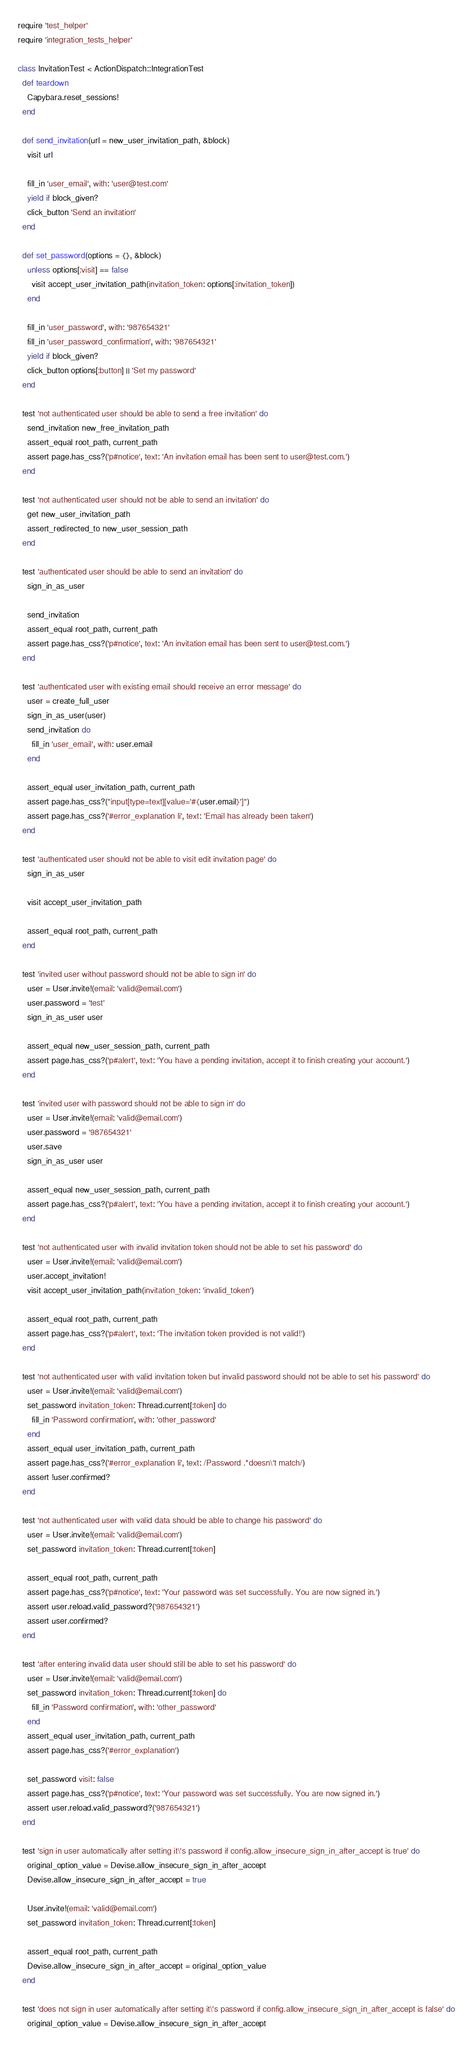<code> <loc_0><loc_0><loc_500><loc_500><_Ruby_>require 'test_helper'
require 'integration_tests_helper'

class InvitationTest < ActionDispatch::IntegrationTest
  def teardown
    Capybara.reset_sessions!
  end

  def send_invitation(url = new_user_invitation_path, &block)
    visit url

    fill_in 'user_email', with: 'user@test.com'
    yield if block_given?
    click_button 'Send an invitation'
  end

  def set_password(options = {}, &block)
    unless options[:visit] == false
      visit accept_user_invitation_path(invitation_token: options[:invitation_token])
    end

    fill_in 'user_password', with: '987654321'
    fill_in 'user_password_confirmation', with: '987654321'
    yield if block_given?
    click_button options[:button] || 'Set my password'
  end

  test 'not authenticated user should be able to send a free invitation' do
    send_invitation new_free_invitation_path
    assert_equal root_path, current_path
    assert page.has_css?('p#notice', text: 'An invitation email has been sent to user@test.com.')
  end

  test 'not authenticated user should not be able to send an invitation' do
    get new_user_invitation_path
    assert_redirected_to new_user_session_path
  end

  test 'authenticated user should be able to send an invitation' do
    sign_in_as_user

    send_invitation
    assert_equal root_path, current_path
    assert page.has_css?('p#notice', text: 'An invitation email has been sent to user@test.com.')
  end

  test 'authenticated user with existing email should receive an error message' do
    user = create_full_user
    sign_in_as_user(user)
    send_invitation do
      fill_in 'user_email', with: user.email
    end

    assert_equal user_invitation_path, current_path
    assert page.has_css?("input[type=text][value='#{user.email}']")
    assert page.has_css?('#error_explanation li', text: 'Email has already been taken')
  end

  test 'authenticated user should not be able to visit edit invitation page' do
    sign_in_as_user

    visit accept_user_invitation_path

    assert_equal root_path, current_path
  end

  test 'invited user without password should not be able to sign in' do
    user = User.invite!(email: 'valid@email.com')
    user.password = 'test'
    sign_in_as_user user

    assert_equal new_user_session_path, current_path
    assert page.has_css?('p#alert', text: 'You have a pending invitation, accept it to finish creating your account.')
  end

  test 'invited user with password should not be able to sign in' do
    user = User.invite!(email: 'valid@email.com')
    user.password = '987654321'
    user.save
    sign_in_as_user user

    assert_equal new_user_session_path, current_path
    assert page.has_css?('p#alert', text: 'You have a pending invitation, accept it to finish creating your account.')
  end

  test 'not authenticated user with invalid invitation token should not be able to set his password' do
    user = User.invite!(email: 'valid@email.com')
    user.accept_invitation!
    visit accept_user_invitation_path(invitation_token: 'invalid_token')

    assert_equal root_path, current_path
    assert page.has_css?('p#alert', text: 'The invitation token provided is not valid!')
  end

  test 'not authenticated user with valid invitation token but invalid password should not be able to set his password' do
    user = User.invite!(email: 'valid@email.com')
    set_password invitation_token: Thread.current[:token] do
      fill_in 'Password confirmation', with: 'other_password'
    end
    assert_equal user_invitation_path, current_path
    assert page.has_css?('#error_explanation li', text: /Password .*doesn\'t match/)
    assert !user.confirmed?
  end

  test 'not authenticated user with valid data should be able to change his password' do
    user = User.invite!(email: 'valid@email.com')
    set_password invitation_token: Thread.current[:token]

    assert_equal root_path, current_path
    assert page.has_css?('p#notice', text: 'Your password was set successfully. You are now signed in.')
    assert user.reload.valid_password?('987654321')
    assert user.confirmed?
  end

  test 'after entering invalid data user should still be able to set his password' do
    user = User.invite!(email: 'valid@email.com')
    set_password invitation_token: Thread.current[:token] do
      fill_in 'Password confirmation', with: 'other_password'
    end
    assert_equal user_invitation_path, current_path
    assert page.has_css?('#error_explanation')

    set_password visit: false
    assert page.has_css?('p#notice', text: 'Your password was set successfully. You are now signed in.')
    assert user.reload.valid_password?('987654321')
  end

  test 'sign in user automatically after setting it\'s password if config.allow_insecure_sign_in_after_accept is true' do
    original_option_value = Devise.allow_insecure_sign_in_after_accept
    Devise.allow_insecure_sign_in_after_accept = true

    User.invite!(email: 'valid@email.com')
    set_password invitation_token: Thread.current[:token]

    assert_equal root_path, current_path
    Devise.allow_insecure_sign_in_after_accept = original_option_value
  end

  test 'does not sign in user automatically after setting it\'s password if config.allow_insecure_sign_in_after_accept is false' do
    original_option_value = Devise.allow_insecure_sign_in_after_accept</code> 